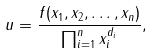Convert formula to latex. <formula><loc_0><loc_0><loc_500><loc_500>u = \frac { f ( x _ { 1 } , x _ { 2 } , \dots , x _ { n } ) } { \prod _ { i = 1 } ^ { n } x _ { i } ^ { d _ { i } } } ,</formula> 